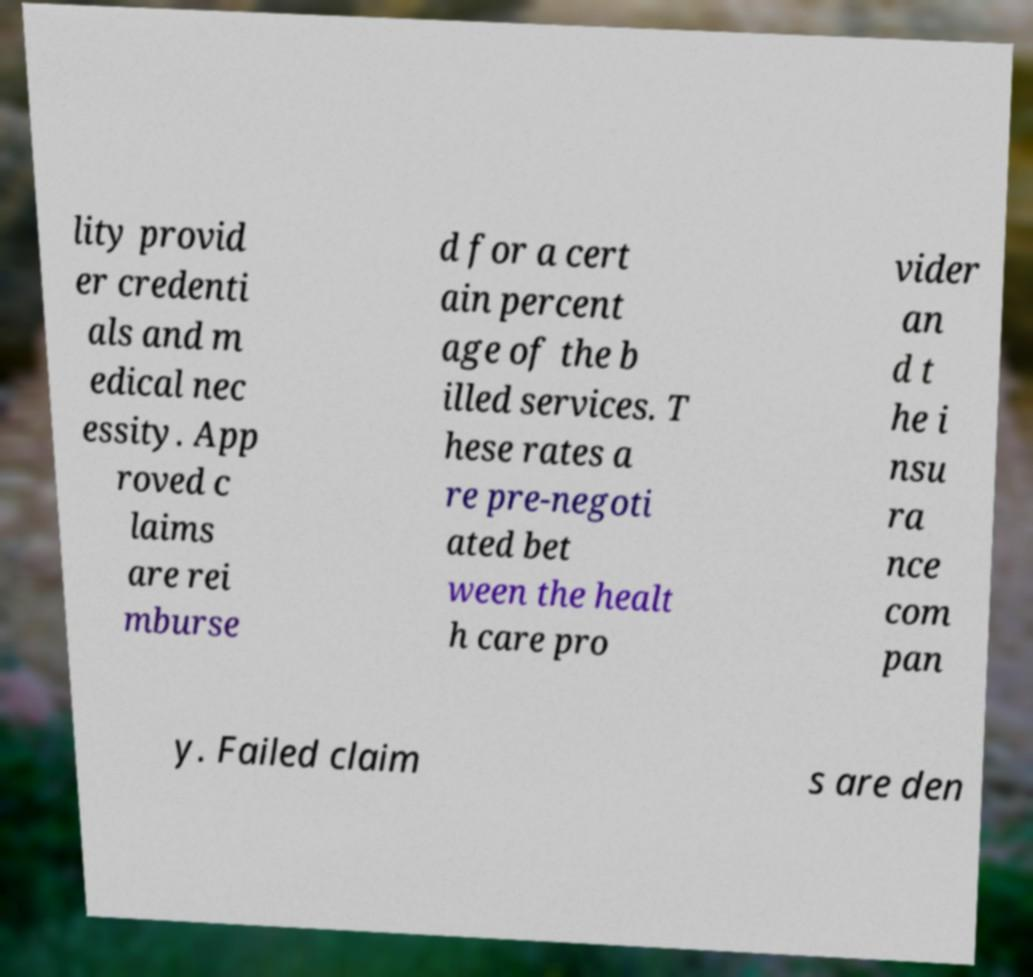Please identify and transcribe the text found in this image. lity provid er credenti als and m edical nec essity. App roved c laims are rei mburse d for a cert ain percent age of the b illed services. T hese rates a re pre-negoti ated bet ween the healt h care pro vider an d t he i nsu ra nce com pan y. Failed claim s are den 